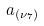<formula> <loc_0><loc_0><loc_500><loc_500>a _ { ( \nu _ { 7 } ) }</formula> 